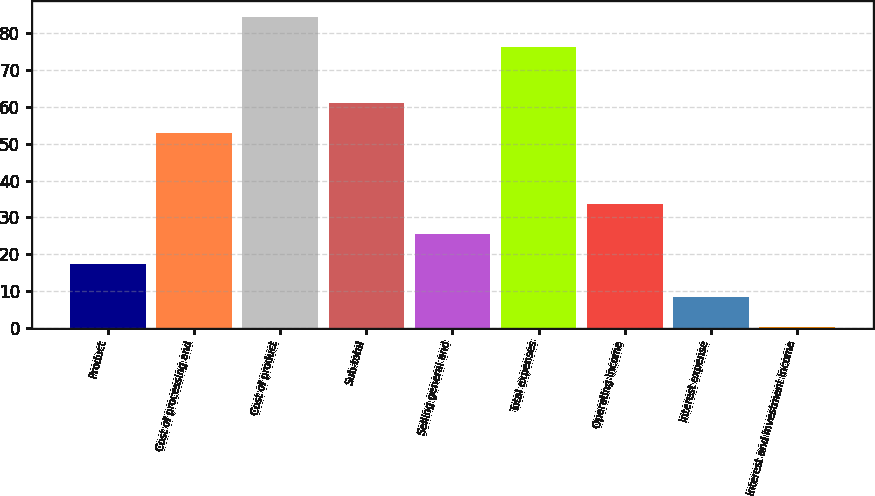Convert chart to OTSL. <chart><loc_0><loc_0><loc_500><loc_500><bar_chart><fcel>Product<fcel>Cost of processing and<fcel>Cost of product<fcel>Sub-total<fcel>Selling general and<fcel>Total expenses<fcel>Operating income<fcel>Interest expense<fcel>Interest and investment income<nl><fcel>17.4<fcel>52.9<fcel>84.5<fcel>61<fcel>25.5<fcel>76.4<fcel>33.6<fcel>8.3<fcel>0.2<nl></chart> 